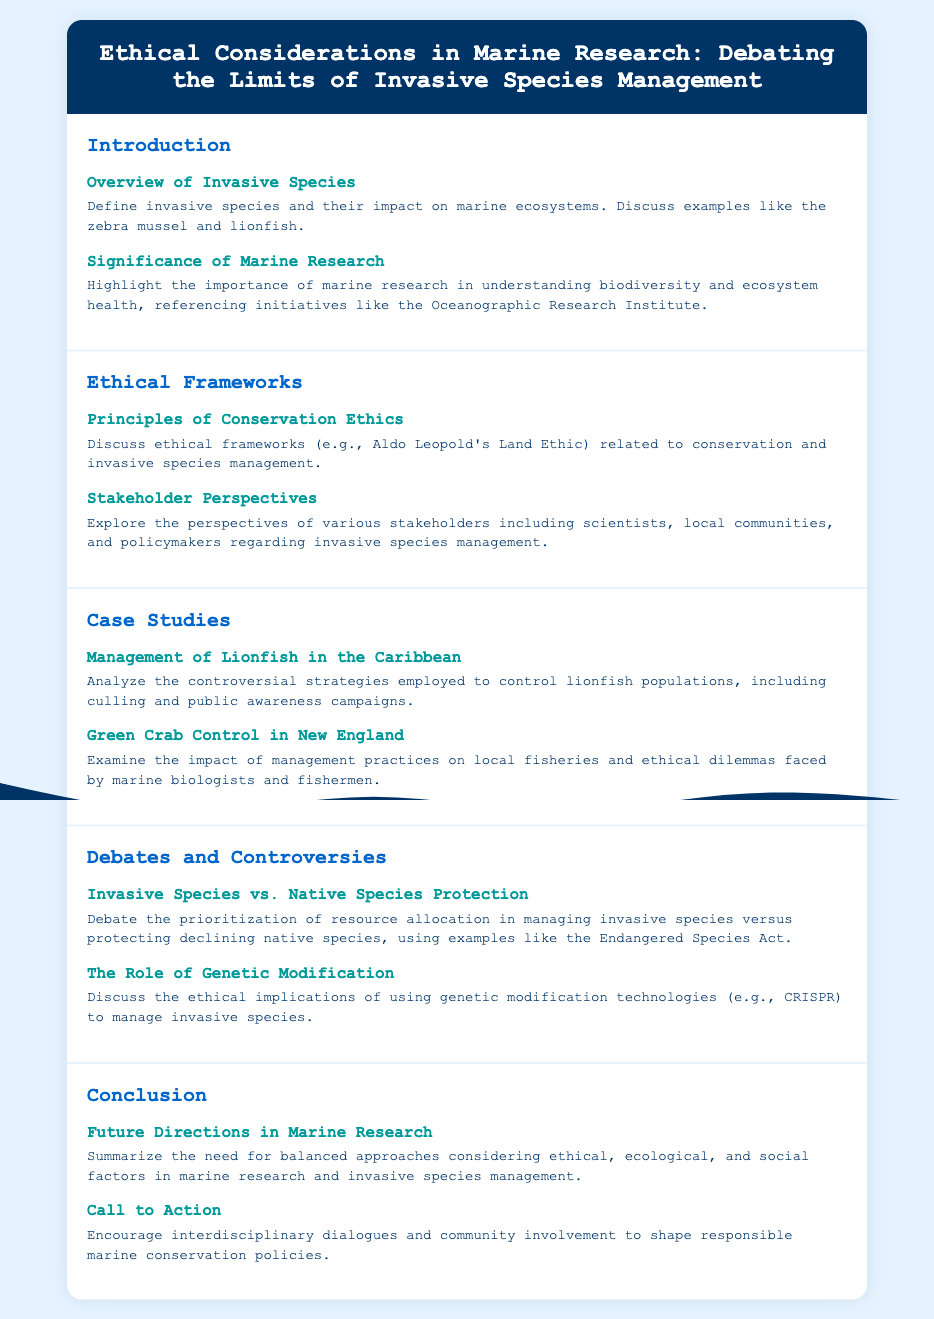What is the title of the document? The title of the document is located in the header and outlines its main theme regarding marine research ethics.
Answer: Ethical Considerations in Marine Research: Debating the Limits of Invasive Species Management What are two examples of invasive species mentioned? The document discusses specific examples of invasive species and lists them under the Overview of Invasive Species section.
Answer: Zebra mussel and lionfish What ethical framework is referenced in the document? The principles of conservation ethics are discussed, mentioning a well-known framework linked to conservation.
Answer: Aldo Leopold's Land Ethic What impact do management practices have according to the document? The document examines the consequences of certain practices on local fisheries, highlighting the ethical dilemmas presented.
Answer: Local fisheries What is one debated topic mentioned in the document? The document outlines various controversies, briefly indicating a specific area of debate in invasive species management.
Answer: Invasive Species vs. Native Species Protection How does the document suggest addressing invasive species management? The conclusion hints at a broader perspective/approach required for effective management of invasive species.
Answer: Interdisciplinary dialogues and community involvement 